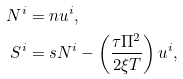Convert formula to latex. <formula><loc_0><loc_0><loc_500><loc_500>N ^ { i } & = n u ^ { i } , \\ S ^ { i } & = s N ^ { i } - \left ( \frac { \tau \Pi ^ { 2 } } { 2 \xi T } \right ) u ^ { i } ,</formula> 